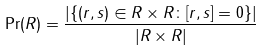Convert formula to latex. <formula><loc_0><loc_0><loc_500><loc_500>\Pr ( R ) = \frac { | \{ ( r , s ) \in R \times R \colon [ r , s ] = 0 \} | } { | R \times R | }</formula> 